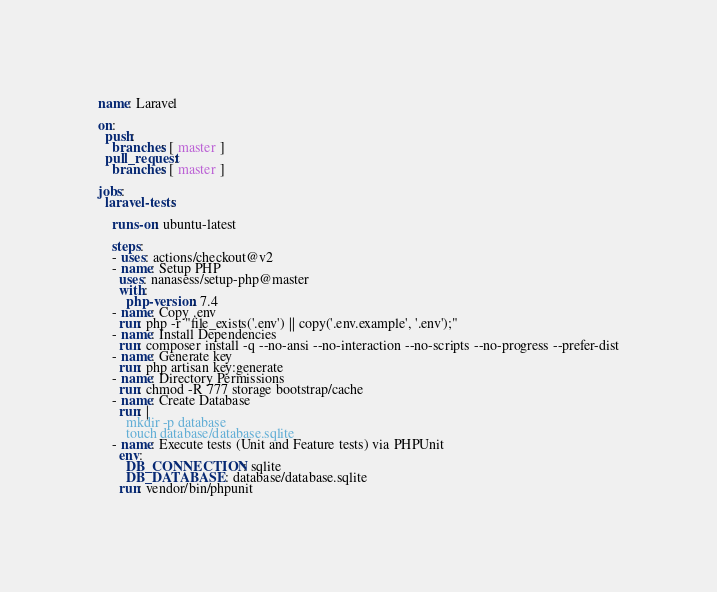<code> <loc_0><loc_0><loc_500><loc_500><_YAML_>name: Laravel

on:
  push:
    branches: [ master ]
  pull_request:
    branches: [ master ]

jobs:
  laravel-tests:

    runs-on: ubuntu-latest

    steps:
    - uses: actions/checkout@v2
    - name: Setup PHP
      uses: nanasess/setup-php@master
      with:
        php-version: 7.4
    - name: Copy .env
      run: php -r "file_exists('.env') || copy('.env.example', '.env');"
    - name: Install Dependencies
      run: composer install -q --no-ansi --no-interaction --no-scripts --no-progress --prefer-dist
    - name: Generate key
      run: php artisan key:generate
    - name: Directory Permissions
      run: chmod -R 777 storage bootstrap/cache
    - name: Create Database
      run: |
        mkdir -p database
        touch database/database.sqlite
    - name: Execute tests (Unit and Feature tests) via PHPUnit
      env:
        DB_CONNECTION: sqlite
        DB_DATABASE: database/database.sqlite
      run: vendor/bin/phpunit
</code> 